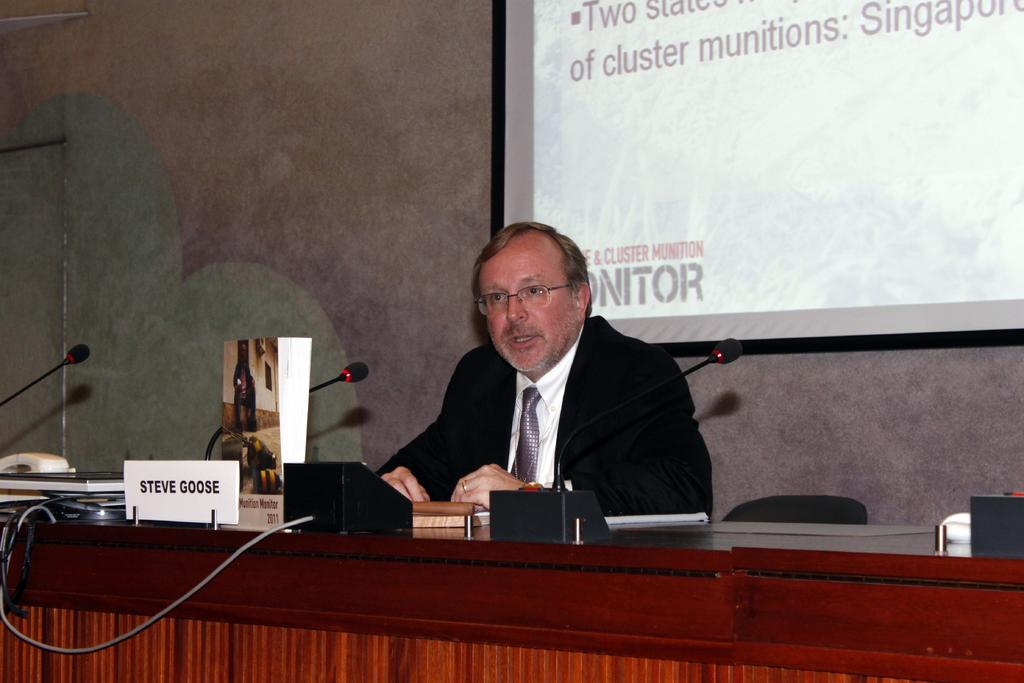What is the person in the image doing? There is a person sitting in the image. What can be seen on the desk in the image? There are objects on a desk in the image. What is visible in the background of the image? There is a wall and a projector in the background of the image. What is being displayed on the projector? There is text visible on the projector. What type of balloon is floating near the person in the image? There is no balloon present in the image. How does the sponge on the desk help the person in the image? There is no sponge present in the image. 